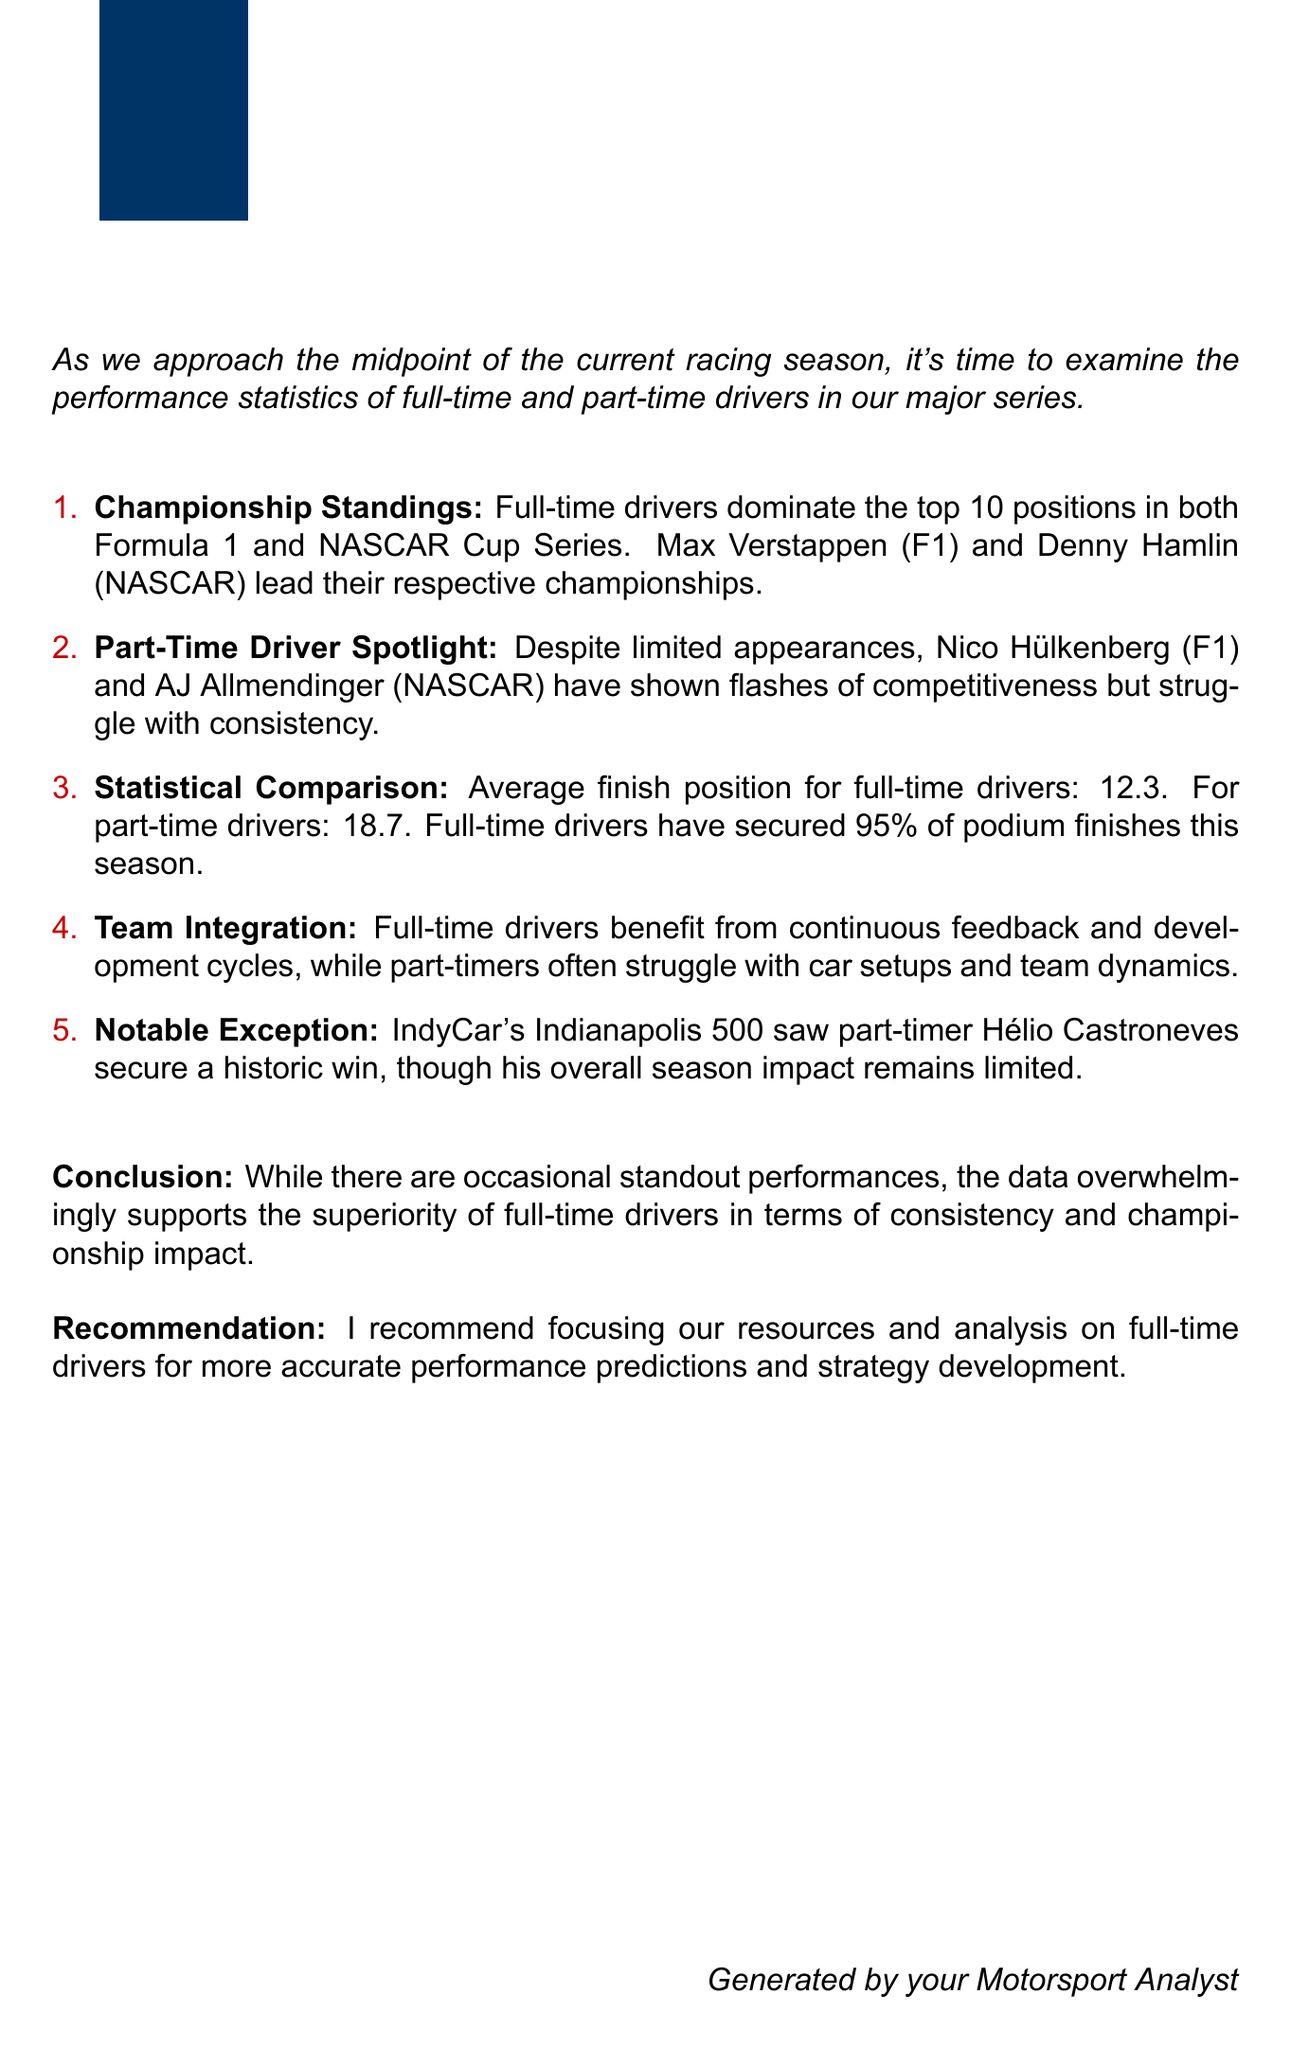What is the average finish position for full-time drivers? The document states that the average finish position for full-time drivers is 12.3.
Answer: 12.3 Who leads the Formula 1 championship? According to the document, Max Verstappen leads the Formula 1 championship.
Answer: Max Verstappen What percentage of podium finishes have full-time drivers secured this season? The document indicates that full-time drivers have secured 95% of podium finishes this season.
Answer: 95% Which part-time driver won the Indianapolis 500? The document mentions that Hélio Castroneves, a part-time driver, secured a historic win at the Indianapolis 500.
Answer: Hélio Castroneves What is the average finish position for part-time drivers? The document indicates that the average finish position for part-time drivers is 18.7.
Answer: 18.7 What is the conclusion regarding full-time vs part-time drivers? The document concludes that the data overwhelmingly supports the superiority of full-time drivers in terms of consistency and championship impact.
Answer: Superiority of full-time drivers How many top positions do full-time drivers dominate? The document states that full-time drivers dominate the top 10 positions.
Answer: Top 10 positions What does the document recommend focusing on for performance predictions? The document recommends focusing resources and analysis on full-time drivers for more accurate performance predictions.
Answer: Full-time drivers 